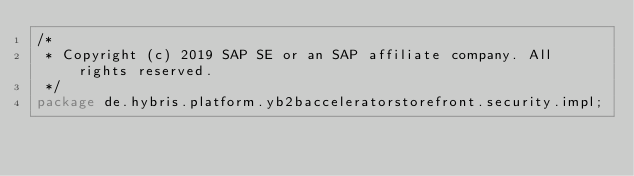Convert code to text. <code><loc_0><loc_0><loc_500><loc_500><_Java_>/*
 * Copyright (c) 2019 SAP SE or an SAP affiliate company. All rights reserved.
 */
package de.hybris.platform.yb2bacceleratorstorefront.security.impl;
</code> 